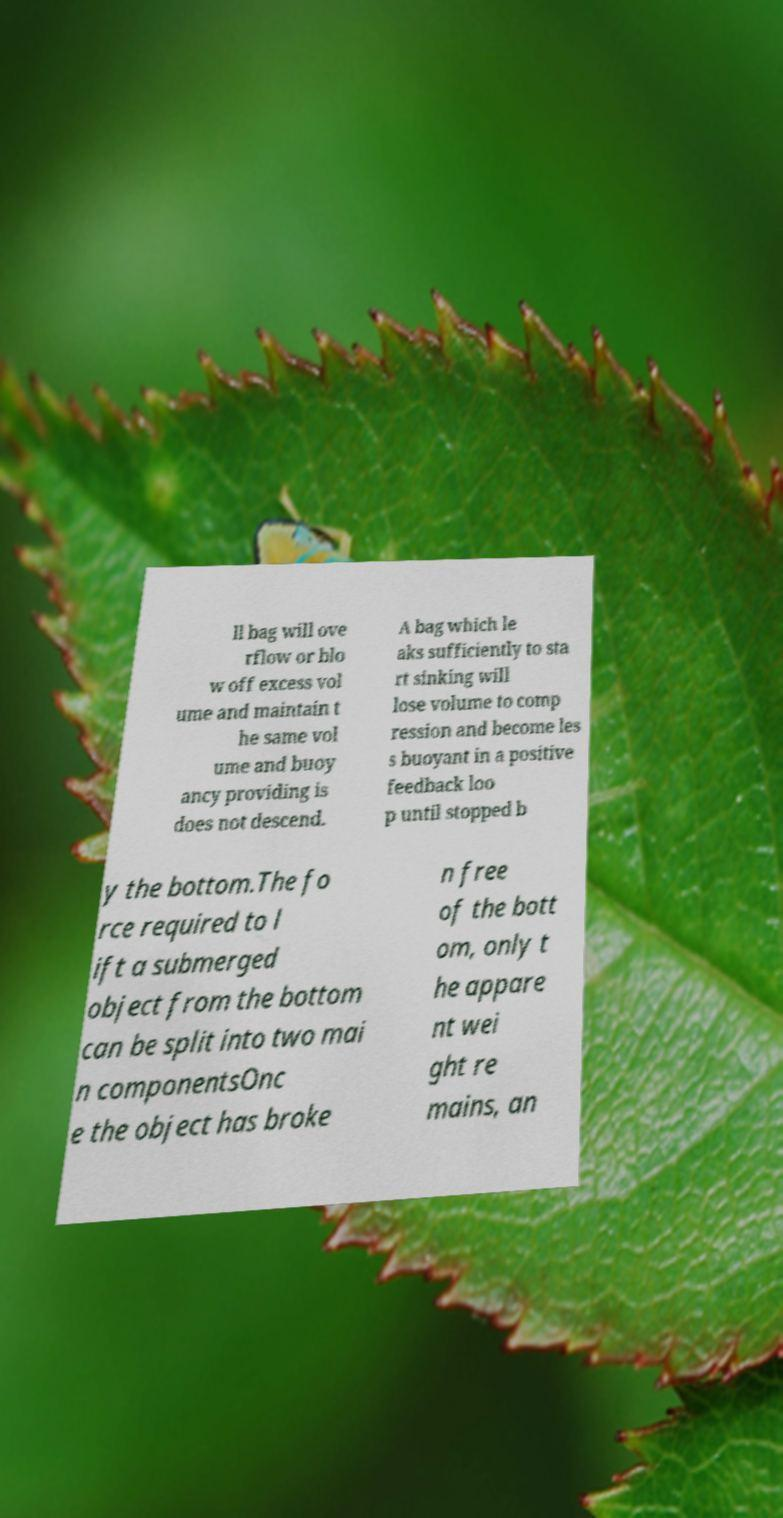Could you assist in decoding the text presented in this image and type it out clearly? ll bag will ove rflow or blo w off excess vol ume and maintain t he same vol ume and buoy ancy providing is does not descend. A bag which le aks sufficiently to sta rt sinking will lose volume to comp ression and become les s buoyant in a positive feedback loo p until stopped b y the bottom.The fo rce required to l ift a submerged object from the bottom can be split into two mai n componentsOnc e the object has broke n free of the bott om, only t he appare nt wei ght re mains, an 